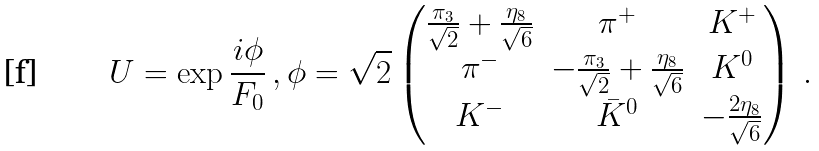<formula> <loc_0><loc_0><loc_500><loc_500>U = \exp \frac { i \phi } { F _ { 0 } } \, , \phi = \sqrt { 2 } \begin{pmatrix} \frac { \pi _ { 3 } } { \sqrt { 2 } } + \frac { \eta _ { 8 } } { \sqrt { 6 } } & \pi ^ { + } & K ^ { + } \\ \pi ^ { - } & - \frac { \pi _ { 3 } } { \sqrt { 2 } } + \frac { \eta _ { 8 } } { \sqrt { 6 } } & K ^ { 0 } \\ K ^ { - } & \bar { K } ^ { 0 } & - \frac { 2 \eta _ { 8 } } { \sqrt { 6 } } \end{pmatrix} \, .</formula> 